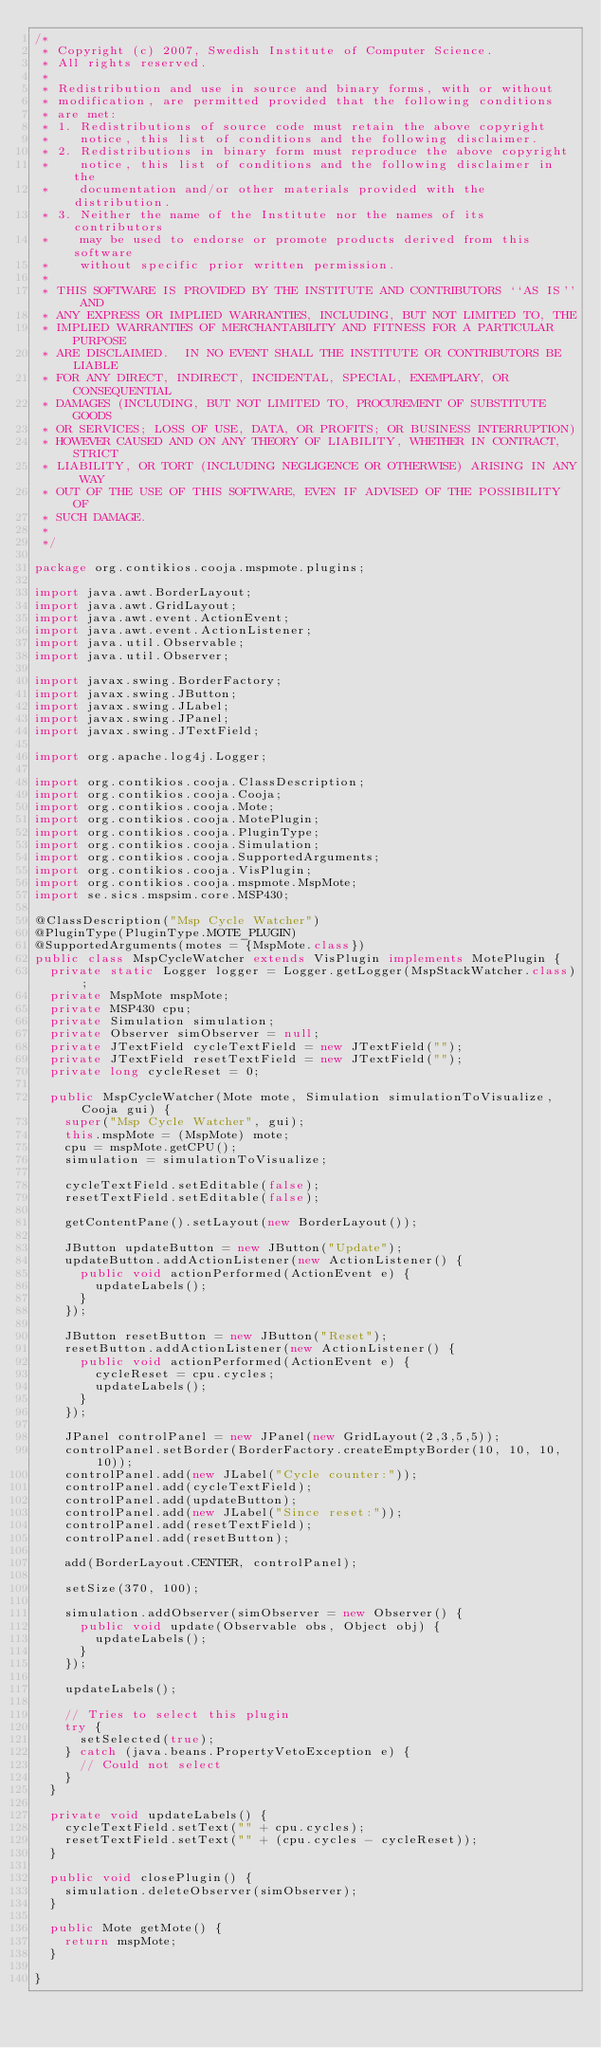Convert code to text. <code><loc_0><loc_0><loc_500><loc_500><_Java_>/*
 * Copyright (c) 2007, Swedish Institute of Computer Science.
 * All rights reserved.
 *
 * Redistribution and use in source and binary forms, with or without
 * modification, are permitted provided that the following conditions
 * are met:
 * 1. Redistributions of source code must retain the above copyright
 *    notice, this list of conditions and the following disclaimer.
 * 2. Redistributions in binary form must reproduce the above copyright
 *    notice, this list of conditions and the following disclaimer in the
 *    documentation and/or other materials provided with the distribution.
 * 3. Neither the name of the Institute nor the names of its contributors
 *    may be used to endorse or promote products derived from this software
 *    without specific prior written permission.
 *
 * THIS SOFTWARE IS PROVIDED BY THE INSTITUTE AND CONTRIBUTORS ``AS IS'' AND
 * ANY EXPRESS OR IMPLIED WARRANTIES, INCLUDING, BUT NOT LIMITED TO, THE
 * IMPLIED WARRANTIES OF MERCHANTABILITY AND FITNESS FOR A PARTICULAR PURPOSE
 * ARE DISCLAIMED.  IN NO EVENT SHALL THE INSTITUTE OR CONTRIBUTORS BE LIABLE
 * FOR ANY DIRECT, INDIRECT, INCIDENTAL, SPECIAL, EXEMPLARY, OR CONSEQUENTIAL
 * DAMAGES (INCLUDING, BUT NOT LIMITED TO, PROCUREMENT OF SUBSTITUTE GOODS
 * OR SERVICES; LOSS OF USE, DATA, OR PROFITS; OR BUSINESS INTERRUPTION)
 * HOWEVER CAUSED AND ON ANY THEORY OF LIABILITY, WHETHER IN CONTRACT, STRICT
 * LIABILITY, OR TORT (INCLUDING NEGLIGENCE OR OTHERWISE) ARISING IN ANY WAY
 * OUT OF THE USE OF THIS SOFTWARE, EVEN IF ADVISED OF THE POSSIBILITY OF
 * SUCH DAMAGE.
 *
 */

package org.contikios.cooja.mspmote.plugins;

import java.awt.BorderLayout;
import java.awt.GridLayout;
import java.awt.event.ActionEvent;
import java.awt.event.ActionListener;
import java.util.Observable;
import java.util.Observer;

import javax.swing.BorderFactory;
import javax.swing.JButton;
import javax.swing.JLabel;
import javax.swing.JPanel;
import javax.swing.JTextField;

import org.apache.log4j.Logger;

import org.contikios.cooja.ClassDescription;
import org.contikios.cooja.Cooja;
import org.contikios.cooja.Mote;
import org.contikios.cooja.MotePlugin;
import org.contikios.cooja.PluginType;
import org.contikios.cooja.Simulation;
import org.contikios.cooja.SupportedArguments;
import org.contikios.cooja.VisPlugin;
import org.contikios.cooja.mspmote.MspMote;
import se.sics.mspsim.core.MSP430;

@ClassDescription("Msp Cycle Watcher")
@PluginType(PluginType.MOTE_PLUGIN)
@SupportedArguments(motes = {MspMote.class})
public class MspCycleWatcher extends VisPlugin implements MotePlugin {
  private static Logger logger = Logger.getLogger(MspStackWatcher.class);
  private MspMote mspMote;
  private MSP430 cpu;
  private Simulation simulation;
  private Observer simObserver = null;
  private JTextField cycleTextField = new JTextField("");
  private JTextField resetTextField = new JTextField("");
  private long cycleReset = 0;

  public MspCycleWatcher(Mote mote, Simulation simulationToVisualize, Cooja gui) {
    super("Msp Cycle Watcher", gui);
    this.mspMote = (MspMote) mote;
    cpu = mspMote.getCPU();
    simulation = simulationToVisualize;

    cycleTextField.setEditable(false);
    resetTextField.setEditable(false);

    getContentPane().setLayout(new BorderLayout());

    JButton updateButton = new JButton("Update");
    updateButton.addActionListener(new ActionListener() {
      public void actionPerformed(ActionEvent e) {
        updateLabels();
      }
    });

    JButton resetButton = new JButton("Reset");
    resetButton.addActionListener(new ActionListener() {
      public void actionPerformed(ActionEvent e) {
        cycleReset = cpu.cycles;
        updateLabels();
      }
    });

    JPanel controlPanel = new JPanel(new GridLayout(2,3,5,5));
    controlPanel.setBorder(BorderFactory.createEmptyBorder(10, 10, 10, 10));
    controlPanel.add(new JLabel("Cycle counter:"));
    controlPanel.add(cycleTextField);
    controlPanel.add(updateButton);
    controlPanel.add(new JLabel("Since reset:"));
    controlPanel.add(resetTextField);
    controlPanel.add(resetButton);

    add(BorderLayout.CENTER, controlPanel);

    setSize(370, 100);

    simulation.addObserver(simObserver = new Observer() {
      public void update(Observable obs, Object obj) {
        updateLabels();
      }
    });

    updateLabels();

    // Tries to select this plugin
    try {
      setSelected(true);
    } catch (java.beans.PropertyVetoException e) {
      // Could not select
    }
  }

  private void updateLabels() {
    cycleTextField.setText("" + cpu.cycles);
    resetTextField.setText("" + (cpu.cycles - cycleReset));
  }

  public void closePlugin() {
    simulation.deleteObserver(simObserver);
  }

  public Mote getMote() {
    return mspMote;
  }

}
</code> 